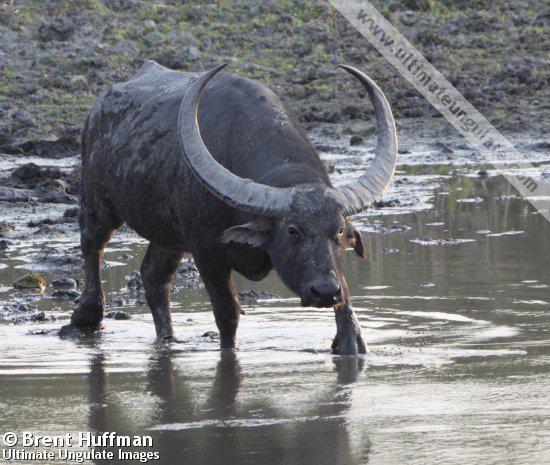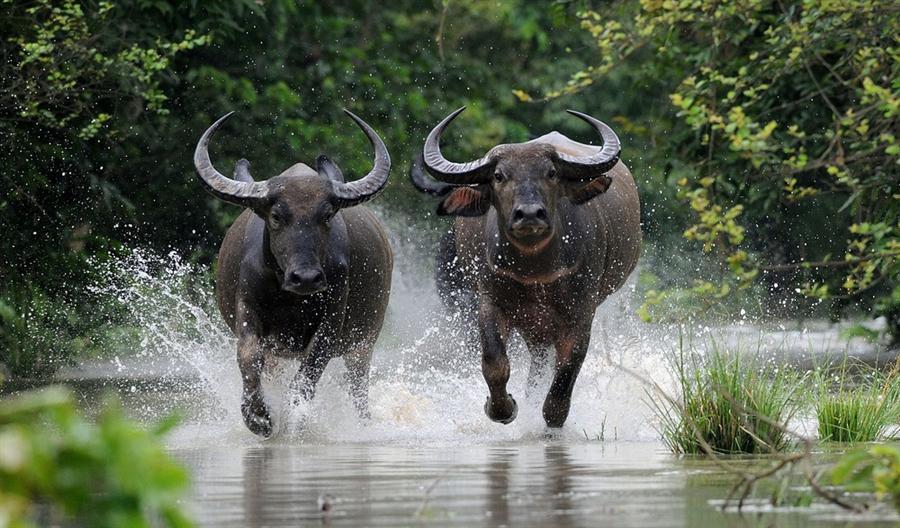The first image is the image on the left, the second image is the image on the right. For the images displayed, is the sentence "At least one ox is standing in the water." factually correct? Answer yes or no. Yes. The first image is the image on the left, the second image is the image on the right. For the images shown, is this caption "Each image contains just one water buffalo." true? Answer yes or no. No. 